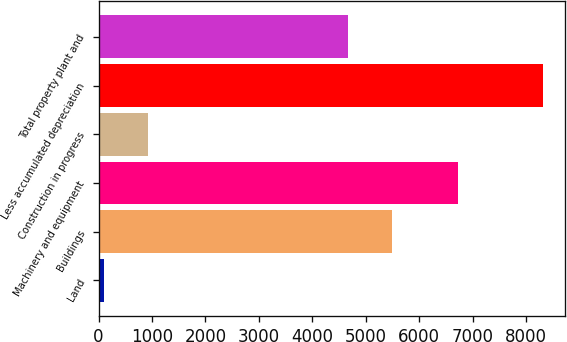Convert chart. <chart><loc_0><loc_0><loc_500><loc_500><bar_chart><fcel>Land<fcel>Buildings<fcel>Machinery and equipment<fcel>Construction in progress<fcel>Less accumulated depreciation<fcel>Total property plant and<nl><fcel>101<fcel>5495.9<fcel>6728<fcel>921.9<fcel>8310<fcel>4675<nl></chart> 